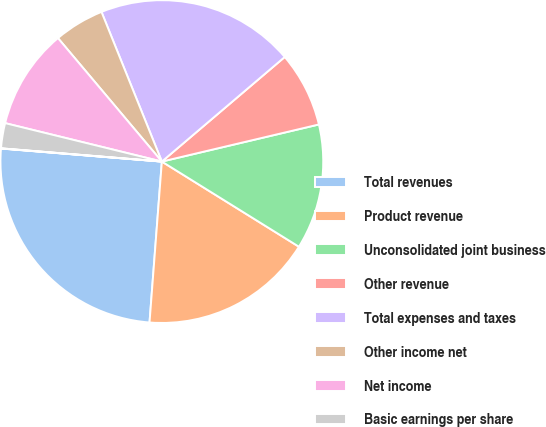Convert chart. <chart><loc_0><loc_0><loc_500><loc_500><pie_chart><fcel>Total revenues<fcel>Product revenue<fcel>Unconsolidated joint business<fcel>Other revenue<fcel>Total expenses and taxes<fcel>Other income net<fcel>Net income<fcel>Basic earnings per share<fcel>Diluted earnings per share<nl><fcel>25.07%<fcel>17.37%<fcel>12.54%<fcel>7.53%<fcel>19.88%<fcel>5.03%<fcel>10.04%<fcel>2.52%<fcel>0.02%<nl></chart> 